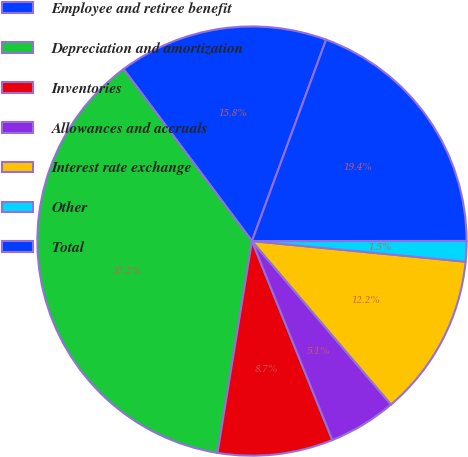<chart> <loc_0><loc_0><loc_500><loc_500><pie_chart><fcel>Employee and retiree benefit<fcel>Depreciation and amortization<fcel>Inventories<fcel>Allowances and accruals<fcel>Interest rate exchange<fcel>Other<fcel>Total<nl><fcel>15.82%<fcel>37.23%<fcel>8.68%<fcel>5.11%<fcel>12.25%<fcel>1.54%<fcel>19.38%<nl></chart> 